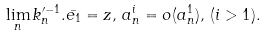Convert formula to latex. <formula><loc_0><loc_0><loc_500><loc_500>\lim _ { n } k _ { n } ^ { \prime - 1 } . \bar { e _ { 1 } } = z , \, a _ { n } ^ { i } = o ( a _ { n } ^ { 1 } ) , \, ( i > 1 ) .</formula> 